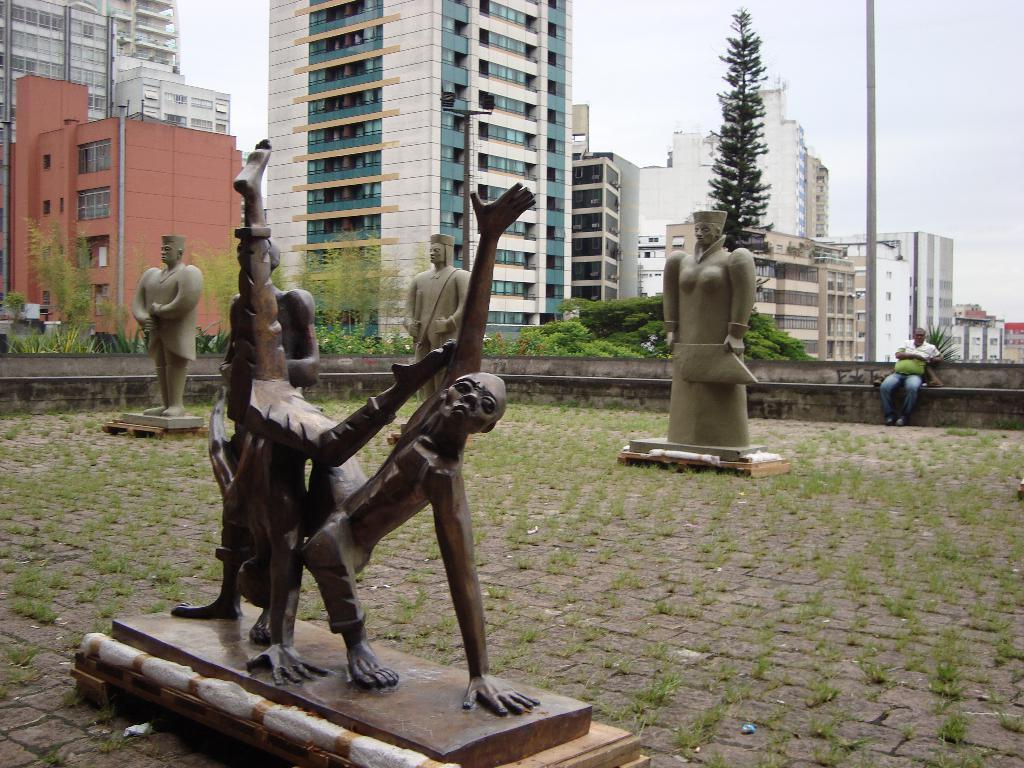What type of objects can be seen in the image? There are statues in the image. What can be seen under the statues? The ground is visible in the image. What type of vegetation is present in the image? There is grass, plants, and trees visible in the image. Can you describe the person in the image? There is a person sitting on a wall in the image. What type of structures are present in the image? Buildings with windows are present in the image. What else can be seen in the image? Poles are visible in the image. What is visible above the statues? The sky is visible in the image. What type of feather can be seen on the person sitting on the wall in the image? There is no feather present on the person sitting on the wall in the image. What type of flesh can be seen on the statues in the image? The statues are not made of flesh, and therefore no flesh can be seen on them. 